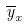<formula> <loc_0><loc_0><loc_500><loc_500>\overline { y } _ { x }</formula> 